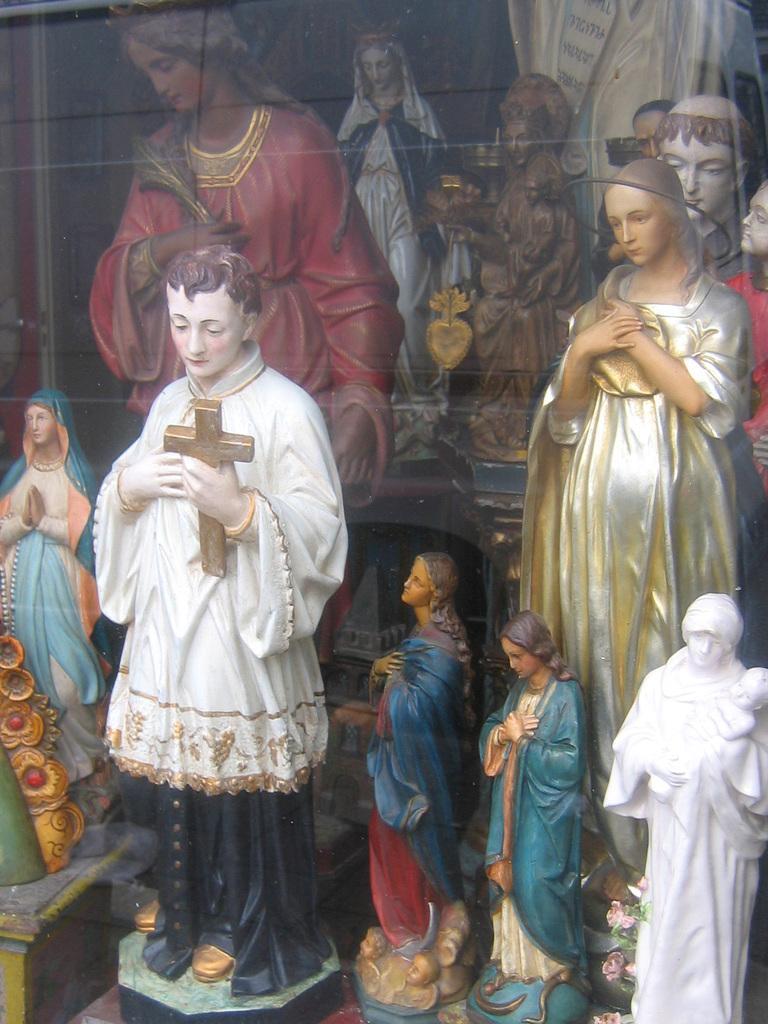In one or two sentences, can you explain what this image depicts? In this image, we can see some statues. 